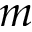Convert formula to latex. <formula><loc_0><loc_0><loc_500><loc_500>m</formula> 